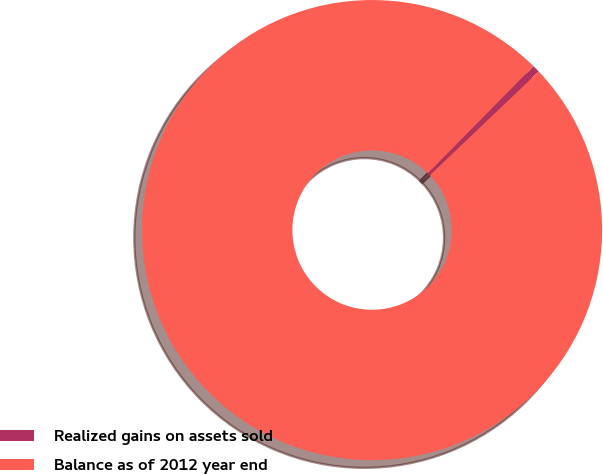<chart> <loc_0><loc_0><loc_500><loc_500><pie_chart><fcel>Realized gains on assets sold<fcel>Balance as of 2012 year end<nl><fcel>0.51%<fcel>99.49%<nl></chart> 